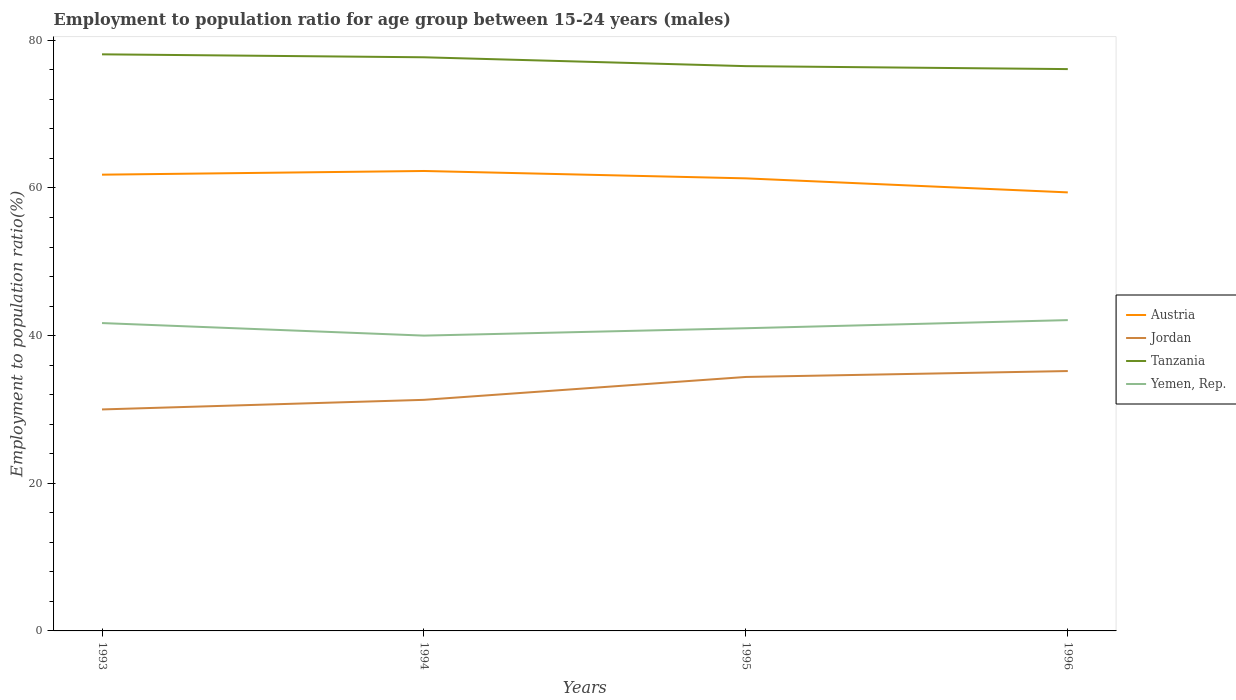Does the line corresponding to Yemen, Rep. intersect with the line corresponding to Jordan?
Your answer should be very brief. No. Is the number of lines equal to the number of legend labels?
Make the answer very short. Yes. In which year was the employment to population ratio in Jordan maximum?
Your response must be concise. 1993. What is the total employment to population ratio in Austria in the graph?
Ensure brevity in your answer.  -0.5. What is the difference between the highest and the second highest employment to population ratio in Yemen, Rep.?
Ensure brevity in your answer.  2.1. Is the employment to population ratio in Austria strictly greater than the employment to population ratio in Tanzania over the years?
Provide a succinct answer. Yes. Does the graph contain any zero values?
Ensure brevity in your answer.  No. Where does the legend appear in the graph?
Provide a short and direct response. Center right. How many legend labels are there?
Your answer should be very brief. 4. How are the legend labels stacked?
Ensure brevity in your answer.  Vertical. What is the title of the graph?
Your answer should be very brief. Employment to population ratio for age group between 15-24 years (males). What is the label or title of the X-axis?
Offer a very short reply. Years. What is the Employment to population ratio(%) in Austria in 1993?
Ensure brevity in your answer.  61.8. What is the Employment to population ratio(%) in Jordan in 1993?
Offer a terse response. 30. What is the Employment to population ratio(%) of Tanzania in 1993?
Offer a very short reply. 78.1. What is the Employment to population ratio(%) of Yemen, Rep. in 1993?
Keep it short and to the point. 41.7. What is the Employment to population ratio(%) of Austria in 1994?
Your response must be concise. 62.3. What is the Employment to population ratio(%) in Jordan in 1994?
Your answer should be very brief. 31.3. What is the Employment to population ratio(%) in Tanzania in 1994?
Give a very brief answer. 77.7. What is the Employment to population ratio(%) in Yemen, Rep. in 1994?
Your answer should be very brief. 40. What is the Employment to population ratio(%) in Austria in 1995?
Your answer should be compact. 61.3. What is the Employment to population ratio(%) in Jordan in 1995?
Provide a succinct answer. 34.4. What is the Employment to population ratio(%) of Tanzania in 1995?
Keep it short and to the point. 76.5. What is the Employment to population ratio(%) of Yemen, Rep. in 1995?
Offer a terse response. 41. What is the Employment to population ratio(%) of Austria in 1996?
Ensure brevity in your answer.  59.4. What is the Employment to population ratio(%) in Jordan in 1996?
Ensure brevity in your answer.  35.2. What is the Employment to population ratio(%) in Tanzania in 1996?
Ensure brevity in your answer.  76.1. What is the Employment to population ratio(%) in Yemen, Rep. in 1996?
Your response must be concise. 42.1. Across all years, what is the maximum Employment to population ratio(%) in Austria?
Provide a short and direct response. 62.3. Across all years, what is the maximum Employment to population ratio(%) in Jordan?
Provide a succinct answer. 35.2. Across all years, what is the maximum Employment to population ratio(%) of Tanzania?
Offer a terse response. 78.1. Across all years, what is the maximum Employment to population ratio(%) in Yemen, Rep.?
Offer a terse response. 42.1. Across all years, what is the minimum Employment to population ratio(%) in Austria?
Your response must be concise. 59.4. Across all years, what is the minimum Employment to population ratio(%) in Jordan?
Your answer should be compact. 30. Across all years, what is the minimum Employment to population ratio(%) in Tanzania?
Make the answer very short. 76.1. What is the total Employment to population ratio(%) of Austria in the graph?
Provide a succinct answer. 244.8. What is the total Employment to population ratio(%) in Jordan in the graph?
Provide a short and direct response. 130.9. What is the total Employment to population ratio(%) of Tanzania in the graph?
Your answer should be very brief. 308.4. What is the total Employment to population ratio(%) in Yemen, Rep. in the graph?
Your answer should be compact. 164.8. What is the difference between the Employment to population ratio(%) of Austria in 1993 and that in 1994?
Provide a succinct answer. -0.5. What is the difference between the Employment to population ratio(%) of Yemen, Rep. in 1993 and that in 1994?
Ensure brevity in your answer.  1.7. What is the difference between the Employment to population ratio(%) in Austria in 1993 and that in 1995?
Give a very brief answer. 0.5. What is the difference between the Employment to population ratio(%) of Jordan in 1993 and that in 1995?
Ensure brevity in your answer.  -4.4. What is the difference between the Employment to population ratio(%) in Tanzania in 1993 and that in 1995?
Your response must be concise. 1.6. What is the difference between the Employment to population ratio(%) in Yemen, Rep. in 1993 and that in 1996?
Provide a succinct answer. -0.4. What is the difference between the Employment to population ratio(%) in Jordan in 1994 and that in 1995?
Offer a very short reply. -3.1. What is the difference between the Employment to population ratio(%) of Tanzania in 1994 and that in 1995?
Ensure brevity in your answer.  1.2. What is the difference between the Employment to population ratio(%) of Yemen, Rep. in 1994 and that in 1995?
Make the answer very short. -1. What is the difference between the Employment to population ratio(%) of Austria in 1994 and that in 1996?
Keep it short and to the point. 2.9. What is the difference between the Employment to population ratio(%) in Tanzania in 1994 and that in 1996?
Give a very brief answer. 1.6. What is the difference between the Employment to population ratio(%) in Yemen, Rep. in 1994 and that in 1996?
Offer a very short reply. -2.1. What is the difference between the Employment to population ratio(%) of Austria in 1993 and the Employment to population ratio(%) of Jordan in 1994?
Make the answer very short. 30.5. What is the difference between the Employment to population ratio(%) in Austria in 1993 and the Employment to population ratio(%) in Tanzania in 1994?
Your response must be concise. -15.9. What is the difference between the Employment to population ratio(%) of Austria in 1993 and the Employment to population ratio(%) of Yemen, Rep. in 1994?
Provide a short and direct response. 21.8. What is the difference between the Employment to population ratio(%) in Jordan in 1993 and the Employment to population ratio(%) in Tanzania in 1994?
Give a very brief answer. -47.7. What is the difference between the Employment to population ratio(%) of Tanzania in 1993 and the Employment to population ratio(%) of Yemen, Rep. in 1994?
Your answer should be compact. 38.1. What is the difference between the Employment to population ratio(%) in Austria in 1993 and the Employment to population ratio(%) in Jordan in 1995?
Ensure brevity in your answer.  27.4. What is the difference between the Employment to population ratio(%) of Austria in 1993 and the Employment to population ratio(%) of Tanzania in 1995?
Give a very brief answer. -14.7. What is the difference between the Employment to population ratio(%) in Austria in 1993 and the Employment to population ratio(%) in Yemen, Rep. in 1995?
Provide a succinct answer. 20.8. What is the difference between the Employment to population ratio(%) of Jordan in 1993 and the Employment to population ratio(%) of Tanzania in 1995?
Make the answer very short. -46.5. What is the difference between the Employment to population ratio(%) in Jordan in 1993 and the Employment to population ratio(%) in Yemen, Rep. in 1995?
Your answer should be very brief. -11. What is the difference between the Employment to population ratio(%) of Tanzania in 1993 and the Employment to population ratio(%) of Yemen, Rep. in 1995?
Ensure brevity in your answer.  37.1. What is the difference between the Employment to population ratio(%) in Austria in 1993 and the Employment to population ratio(%) in Jordan in 1996?
Your answer should be compact. 26.6. What is the difference between the Employment to population ratio(%) in Austria in 1993 and the Employment to population ratio(%) in Tanzania in 1996?
Provide a succinct answer. -14.3. What is the difference between the Employment to population ratio(%) of Austria in 1993 and the Employment to population ratio(%) of Yemen, Rep. in 1996?
Your answer should be compact. 19.7. What is the difference between the Employment to population ratio(%) of Jordan in 1993 and the Employment to population ratio(%) of Tanzania in 1996?
Make the answer very short. -46.1. What is the difference between the Employment to population ratio(%) in Jordan in 1993 and the Employment to population ratio(%) in Yemen, Rep. in 1996?
Your answer should be very brief. -12.1. What is the difference between the Employment to population ratio(%) of Tanzania in 1993 and the Employment to population ratio(%) of Yemen, Rep. in 1996?
Provide a succinct answer. 36. What is the difference between the Employment to population ratio(%) of Austria in 1994 and the Employment to population ratio(%) of Jordan in 1995?
Provide a short and direct response. 27.9. What is the difference between the Employment to population ratio(%) of Austria in 1994 and the Employment to population ratio(%) of Yemen, Rep. in 1995?
Your answer should be very brief. 21.3. What is the difference between the Employment to population ratio(%) of Jordan in 1994 and the Employment to population ratio(%) of Tanzania in 1995?
Provide a succinct answer. -45.2. What is the difference between the Employment to population ratio(%) of Tanzania in 1994 and the Employment to population ratio(%) of Yemen, Rep. in 1995?
Your response must be concise. 36.7. What is the difference between the Employment to population ratio(%) in Austria in 1994 and the Employment to population ratio(%) in Jordan in 1996?
Keep it short and to the point. 27.1. What is the difference between the Employment to population ratio(%) of Austria in 1994 and the Employment to population ratio(%) of Tanzania in 1996?
Keep it short and to the point. -13.8. What is the difference between the Employment to population ratio(%) of Austria in 1994 and the Employment to population ratio(%) of Yemen, Rep. in 1996?
Make the answer very short. 20.2. What is the difference between the Employment to population ratio(%) of Jordan in 1994 and the Employment to population ratio(%) of Tanzania in 1996?
Ensure brevity in your answer.  -44.8. What is the difference between the Employment to population ratio(%) of Jordan in 1994 and the Employment to population ratio(%) of Yemen, Rep. in 1996?
Make the answer very short. -10.8. What is the difference between the Employment to population ratio(%) in Tanzania in 1994 and the Employment to population ratio(%) in Yemen, Rep. in 1996?
Give a very brief answer. 35.6. What is the difference between the Employment to population ratio(%) of Austria in 1995 and the Employment to population ratio(%) of Jordan in 1996?
Keep it short and to the point. 26.1. What is the difference between the Employment to population ratio(%) in Austria in 1995 and the Employment to population ratio(%) in Tanzania in 1996?
Keep it short and to the point. -14.8. What is the difference between the Employment to population ratio(%) of Austria in 1995 and the Employment to population ratio(%) of Yemen, Rep. in 1996?
Keep it short and to the point. 19.2. What is the difference between the Employment to population ratio(%) in Jordan in 1995 and the Employment to population ratio(%) in Tanzania in 1996?
Offer a very short reply. -41.7. What is the difference between the Employment to population ratio(%) in Jordan in 1995 and the Employment to population ratio(%) in Yemen, Rep. in 1996?
Make the answer very short. -7.7. What is the difference between the Employment to population ratio(%) in Tanzania in 1995 and the Employment to population ratio(%) in Yemen, Rep. in 1996?
Provide a short and direct response. 34.4. What is the average Employment to population ratio(%) in Austria per year?
Provide a short and direct response. 61.2. What is the average Employment to population ratio(%) in Jordan per year?
Provide a short and direct response. 32.73. What is the average Employment to population ratio(%) of Tanzania per year?
Offer a very short reply. 77.1. What is the average Employment to population ratio(%) of Yemen, Rep. per year?
Ensure brevity in your answer.  41.2. In the year 1993, what is the difference between the Employment to population ratio(%) in Austria and Employment to population ratio(%) in Jordan?
Ensure brevity in your answer.  31.8. In the year 1993, what is the difference between the Employment to population ratio(%) of Austria and Employment to population ratio(%) of Tanzania?
Keep it short and to the point. -16.3. In the year 1993, what is the difference between the Employment to population ratio(%) in Austria and Employment to population ratio(%) in Yemen, Rep.?
Give a very brief answer. 20.1. In the year 1993, what is the difference between the Employment to population ratio(%) in Jordan and Employment to population ratio(%) in Tanzania?
Offer a terse response. -48.1. In the year 1993, what is the difference between the Employment to population ratio(%) in Tanzania and Employment to population ratio(%) in Yemen, Rep.?
Keep it short and to the point. 36.4. In the year 1994, what is the difference between the Employment to population ratio(%) of Austria and Employment to population ratio(%) of Jordan?
Provide a short and direct response. 31. In the year 1994, what is the difference between the Employment to population ratio(%) in Austria and Employment to population ratio(%) in Tanzania?
Provide a succinct answer. -15.4. In the year 1994, what is the difference between the Employment to population ratio(%) of Austria and Employment to population ratio(%) of Yemen, Rep.?
Offer a very short reply. 22.3. In the year 1994, what is the difference between the Employment to population ratio(%) in Jordan and Employment to population ratio(%) in Tanzania?
Give a very brief answer. -46.4. In the year 1994, what is the difference between the Employment to population ratio(%) in Tanzania and Employment to population ratio(%) in Yemen, Rep.?
Make the answer very short. 37.7. In the year 1995, what is the difference between the Employment to population ratio(%) of Austria and Employment to population ratio(%) of Jordan?
Your answer should be compact. 26.9. In the year 1995, what is the difference between the Employment to population ratio(%) of Austria and Employment to population ratio(%) of Tanzania?
Your response must be concise. -15.2. In the year 1995, what is the difference between the Employment to population ratio(%) in Austria and Employment to population ratio(%) in Yemen, Rep.?
Make the answer very short. 20.3. In the year 1995, what is the difference between the Employment to population ratio(%) in Jordan and Employment to population ratio(%) in Tanzania?
Your response must be concise. -42.1. In the year 1995, what is the difference between the Employment to population ratio(%) of Jordan and Employment to population ratio(%) of Yemen, Rep.?
Ensure brevity in your answer.  -6.6. In the year 1995, what is the difference between the Employment to population ratio(%) of Tanzania and Employment to population ratio(%) of Yemen, Rep.?
Keep it short and to the point. 35.5. In the year 1996, what is the difference between the Employment to population ratio(%) of Austria and Employment to population ratio(%) of Jordan?
Your answer should be very brief. 24.2. In the year 1996, what is the difference between the Employment to population ratio(%) of Austria and Employment to population ratio(%) of Tanzania?
Offer a very short reply. -16.7. In the year 1996, what is the difference between the Employment to population ratio(%) of Austria and Employment to population ratio(%) of Yemen, Rep.?
Provide a succinct answer. 17.3. In the year 1996, what is the difference between the Employment to population ratio(%) in Jordan and Employment to population ratio(%) in Tanzania?
Offer a terse response. -40.9. In the year 1996, what is the difference between the Employment to population ratio(%) of Jordan and Employment to population ratio(%) of Yemen, Rep.?
Provide a short and direct response. -6.9. What is the ratio of the Employment to population ratio(%) of Jordan in 1993 to that in 1994?
Offer a terse response. 0.96. What is the ratio of the Employment to population ratio(%) in Tanzania in 1993 to that in 1994?
Provide a short and direct response. 1.01. What is the ratio of the Employment to population ratio(%) in Yemen, Rep. in 1993 to that in 1994?
Offer a very short reply. 1.04. What is the ratio of the Employment to population ratio(%) of Austria in 1993 to that in 1995?
Give a very brief answer. 1.01. What is the ratio of the Employment to population ratio(%) in Jordan in 1993 to that in 1995?
Provide a short and direct response. 0.87. What is the ratio of the Employment to population ratio(%) of Tanzania in 1993 to that in 1995?
Provide a succinct answer. 1.02. What is the ratio of the Employment to population ratio(%) of Yemen, Rep. in 1993 to that in 1995?
Make the answer very short. 1.02. What is the ratio of the Employment to population ratio(%) of Austria in 1993 to that in 1996?
Your response must be concise. 1.04. What is the ratio of the Employment to population ratio(%) of Jordan in 1993 to that in 1996?
Your answer should be very brief. 0.85. What is the ratio of the Employment to population ratio(%) in Tanzania in 1993 to that in 1996?
Give a very brief answer. 1.03. What is the ratio of the Employment to population ratio(%) in Austria in 1994 to that in 1995?
Give a very brief answer. 1.02. What is the ratio of the Employment to population ratio(%) of Jordan in 1994 to that in 1995?
Your answer should be very brief. 0.91. What is the ratio of the Employment to population ratio(%) in Tanzania in 1994 to that in 1995?
Provide a succinct answer. 1.02. What is the ratio of the Employment to population ratio(%) in Yemen, Rep. in 1994 to that in 1995?
Ensure brevity in your answer.  0.98. What is the ratio of the Employment to population ratio(%) of Austria in 1994 to that in 1996?
Your answer should be compact. 1.05. What is the ratio of the Employment to population ratio(%) of Jordan in 1994 to that in 1996?
Make the answer very short. 0.89. What is the ratio of the Employment to population ratio(%) of Tanzania in 1994 to that in 1996?
Provide a succinct answer. 1.02. What is the ratio of the Employment to population ratio(%) of Yemen, Rep. in 1994 to that in 1996?
Ensure brevity in your answer.  0.95. What is the ratio of the Employment to population ratio(%) of Austria in 1995 to that in 1996?
Provide a succinct answer. 1.03. What is the ratio of the Employment to population ratio(%) in Jordan in 1995 to that in 1996?
Ensure brevity in your answer.  0.98. What is the ratio of the Employment to population ratio(%) in Yemen, Rep. in 1995 to that in 1996?
Your answer should be very brief. 0.97. What is the difference between the highest and the second highest Employment to population ratio(%) of Jordan?
Provide a short and direct response. 0.8. What is the difference between the highest and the second highest Employment to population ratio(%) in Tanzania?
Your answer should be compact. 0.4. What is the difference between the highest and the lowest Employment to population ratio(%) of Tanzania?
Offer a terse response. 2. 